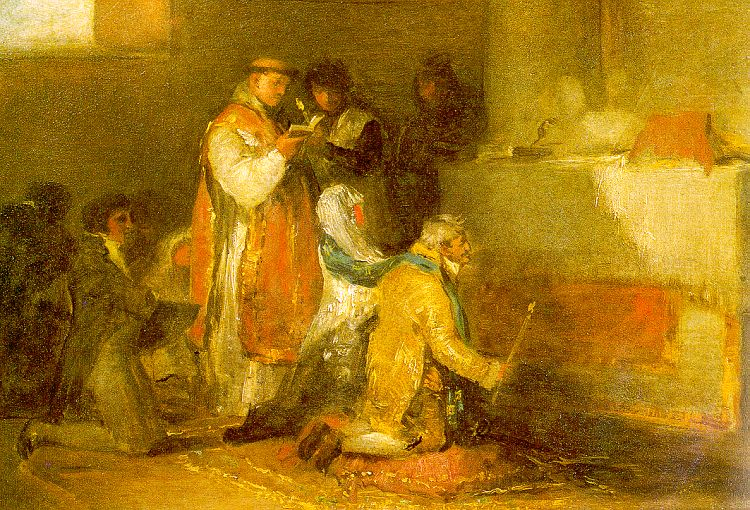What are the key elements in this picture? The image depicts an impressionist oil painting that showcases a scene in a room where several figures are engaged in various activities. The painting predominantly uses warm colors such as yellows, oranges, and browns, creating a cozy and intimate atmosphere. Key figures in the painting include a person in a red robe and another in a blue robe, both standing out against the earth-toned background. They're seen reading books and kneeling, suggesting a scene from everyday life, possibly with a religious or reflective undertone. The style and subject matter hint at this work being from the 19th century, under the genre of genre painting, highlighting moments of daily life through a vivid interplay of light and shadow. 